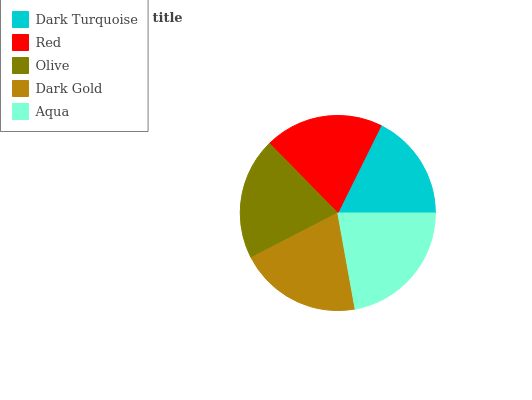Is Dark Turquoise the minimum?
Answer yes or no. Yes. Is Aqua the maximum?
Answer yes or no. Yes. Is Red the minimum?
Answer yes or no. No. Is Red the maximum?
Answer yes or no. No. Is Red greater than Dark Turquoise?
Answer yes or no. Yes. Is Dark Turquoise less than Red?
Answer yes or no. Yes. Is Dark Turquoise greater than Red?
Answer yes or no. No. Is Red less than Dark Turquoise?
Answer yes or no. No. Is Olive the high median?
Answer yes or no. Yes. Is Olive the low median?
Answer yes or no. Yes. Is Aqua the high median?
Answer yes or no. No. Is Red the low median?
Answer yes or no. No. 